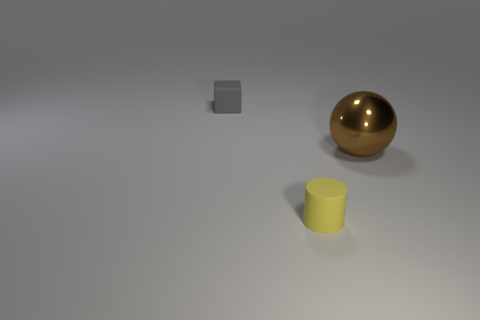Do the tiny yellow thing and the small gray cube have the same material?
Your answer should be compact. Yes. Is there anything else that has the same material as the gray block?
Make the answer very short. Yes. Is the number of large brown shiny balls in front of the large shiny thing greater than the number of large blue things?
Give a very brief answer. No. Do the rubber block and the large thing have the same color?
Your response must be concise. No. There is a gray block that is the same material as the tiny yellow cylinder; what is its size?
Provide a succinct answer. Small. What is the color of the thing that is both in front of the small gray matte thing and left of the large metal thing?
Provide a succinct answer. Yellow. How many brown objects have the same size as the gray block?
Offer a very short reply. 0. What is the size of the thing that is both right of the tiny rubber block and behind the small cylinder?
Your answer should be very brief. Large. How many small yellow cylinders are behind the object in front of the object that is to the right of the yellow matte cylinder?
Your answer should be compact. 0. Are there any small rubber blocks of the same color as the sphere?
Your answer should be very brief. No. 